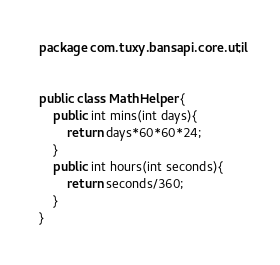Convert code to text. <code><loc_0><loc_0><loc_500><loc_500><_Java_>package com.tuxy.bansapi.core.util;


public class MathHelper {
    public int mins(int days){
        return days*60*60*24;
    }
    public int hours(int seconds){
        return seconds/360;
    }
}
</code> 